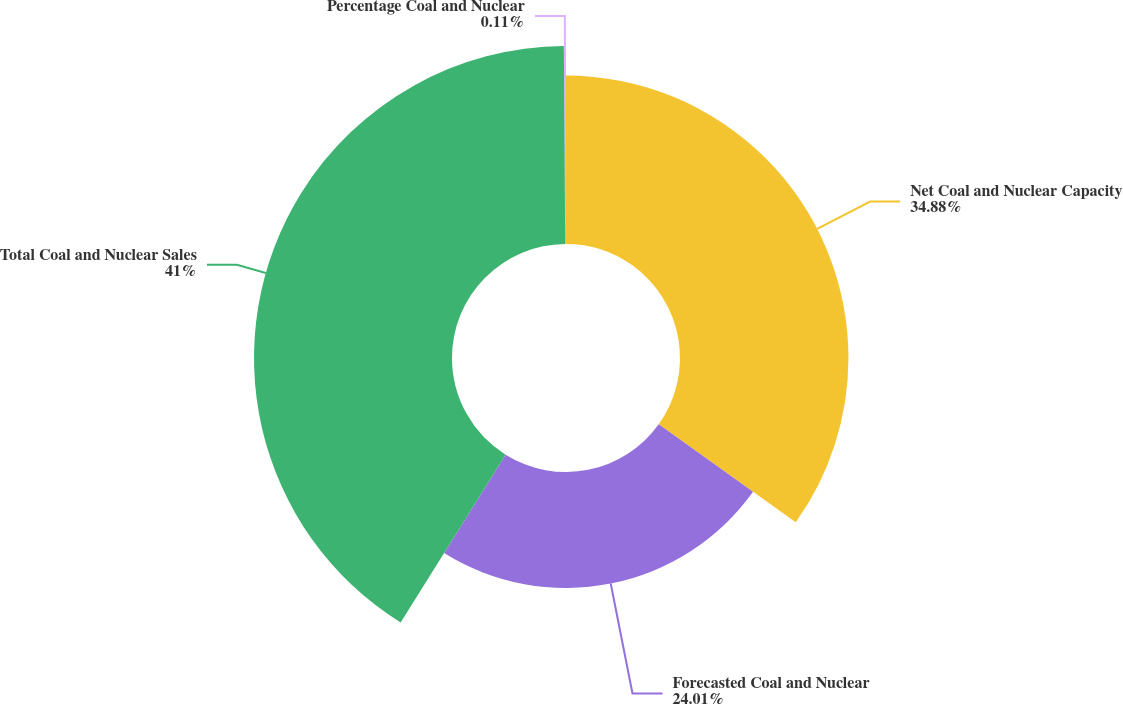Convert chart to OTSL. <chart><loc_0><loc_0><loc_500><loc_500><pie_chart><fcel>Net Coal and Nuclear Capacity<fcel>Forecasted Coal and Nuclear<fcel>Total Coal and Nuclear Sales<fcel>Percentage Coal and Nuclear<nl><fcel>34.88%<fcel>24.01%<fcel>41.0%<fcel>0.11%<nl></chart> 